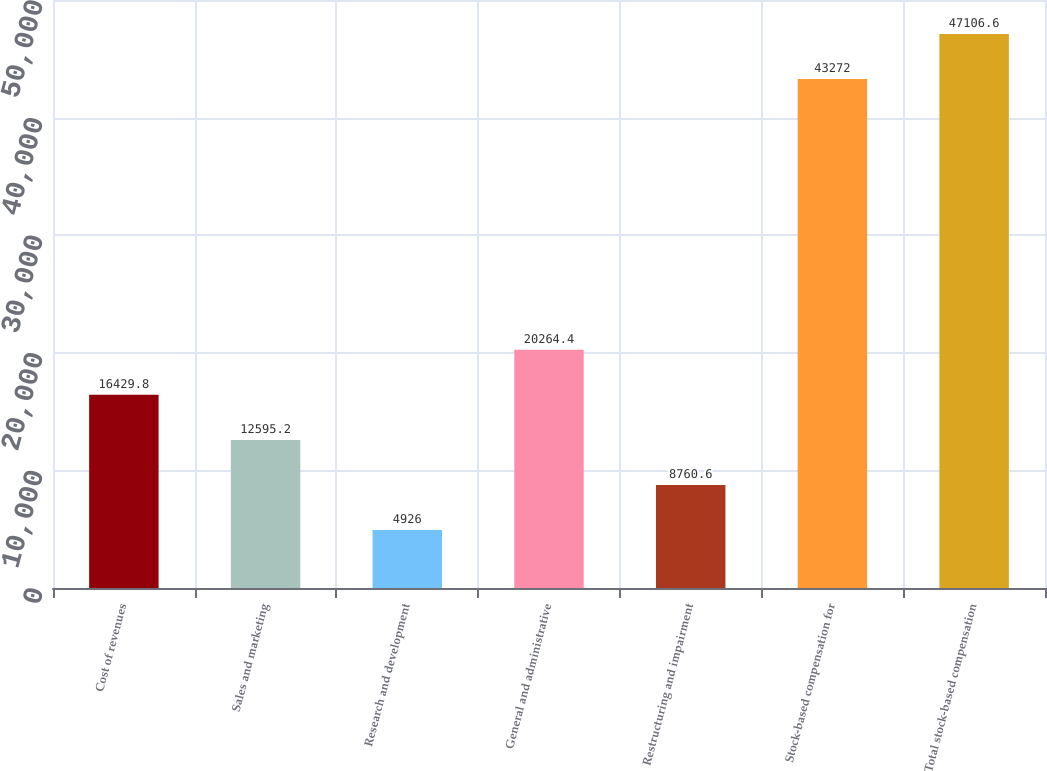<chart> <loc_0><loc_0><loc_500><loc_500><bar_chart><fcel>Cost of revenues<fcel>Sales and marketing<fcel>Research and development<fcel>General and administrative<fcel>Restructuring and impairment<fcel>Stock-based compensation for<fcel>Total stock-based compensation<nl><fcel>16429.8<fcel>12595.2<fcel>4926<fcel>20264.4<fcel>8760.6<fcel>43272<fcel>47106.6<nl></chart> 